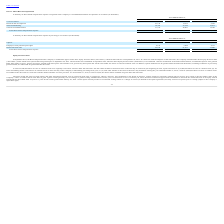From Ringcentral's financial document, What are the respective share-based compensation for cost of revenues in 2018 and 2019? The document shows two values: $4,982 and $8,741 (in thousands). From the document: "Cost of revenues $ 8,741 $ 4,982 $ 3,735 Cost of revenues $ 8,741 $ 4,982 $ 3,735..." Also, What are the respective share-based compensation for research and development in 2018 and 2019? The document shows two values: 14,975 and 23,132 (in thousands). From the document: "Research and development 23,132 14,975 9,550 Research and development 23,132 14,975 9,550..." Also, What are the respective share-based compensation for sales and marketing in 2018 and 2019? The document shows two values: 27,324 and 38,325 (in thousands). From the document: "Sales and marketing 38,325 27,324 16,015 Sales and marketing 38,325 27,324 16,015..." Also, can you calculate: What is the percentage change in share-based compensation for research and development between 2018 and 2019? To answer this question, I need to perform calculations using the financial data. The calculation is: (23,132 - 14,975)/14,975 , which equals 54.47 (percentage). This is based on the information: "Research and development 23,132 14,975 9,550 Research and development 23,132 14,975 9,550..." The key data points involved are: 14,975, 23,132. Also, can you calculate: What is the percentage change in share-based compensation for sales and marketing between 2018 and 2019? To answer this question, I need to perform calculations using the financial data. The calculation is: (31,156 - 20,807)/20,807 , which equals 49.74 (percentage). This is based on the information: "General and administrative 31,156 20,807 12,760 General and administrative 31,156 20,807 12,760..." The key data points involved are: 20,807, 31,156. Also, can you calculate: What is the average share-based compensation expense spent on sales and marketing per year between 2017 to 2019? To answer this question, I need to perform calculations using the financial data. The calculation is: (38,325 + 27,324 + 16,015)/3 , which equals 27221.33 (in thousands). This is based on the information: "Sales and marketing 38,325 27,324 16,015 Sales and marketing 38,325 27,324 16,015 Sales and marketing 38,325 27,324 16,015..." The key data points involved are: 16,015, 27,324, 38,325. 